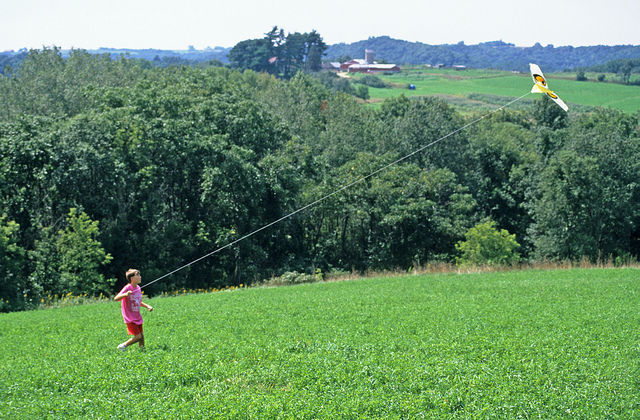What might the child imagine while flying the kite here? As the child watches the kite soar, they might imagine it as a spaceship exploring distant planets, a bird gliding through the skies, or even a mythical creature dancing among the clouds. The expansive green meadow and open skies provide a perfect canvas for their imagination to run wild, creating stories of adventure, freedom, and wonder with every twist and turn of the kite. 